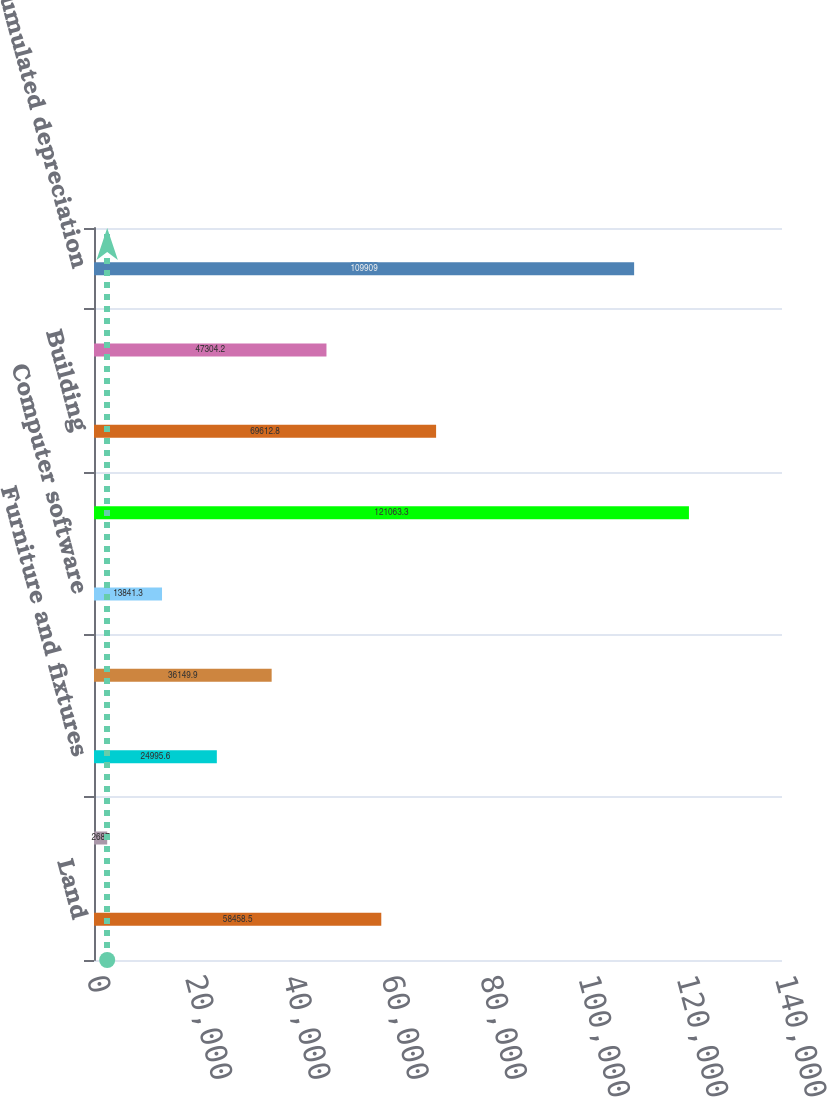Convert chart. <chart><loc_0><loc_0><loc_500><loc_500><bar_chart><fcel>Land<fcel>Leasehold improvements<fcel>Furniture and fixtures<fcel>Office and computer equipment<fcel>Computer software<fcel>Equipment<fcel>Building<fcel>Vehicles<fcel>Less accumulated depreciation<nl><fcel>58458.5<fcel>2687<fcel>24995.6<fcel>36149.9<fcel>13841.3<fcel>121063<fcel>69612.8<fcel>47304.2<fcel>109909<nl></chart> 